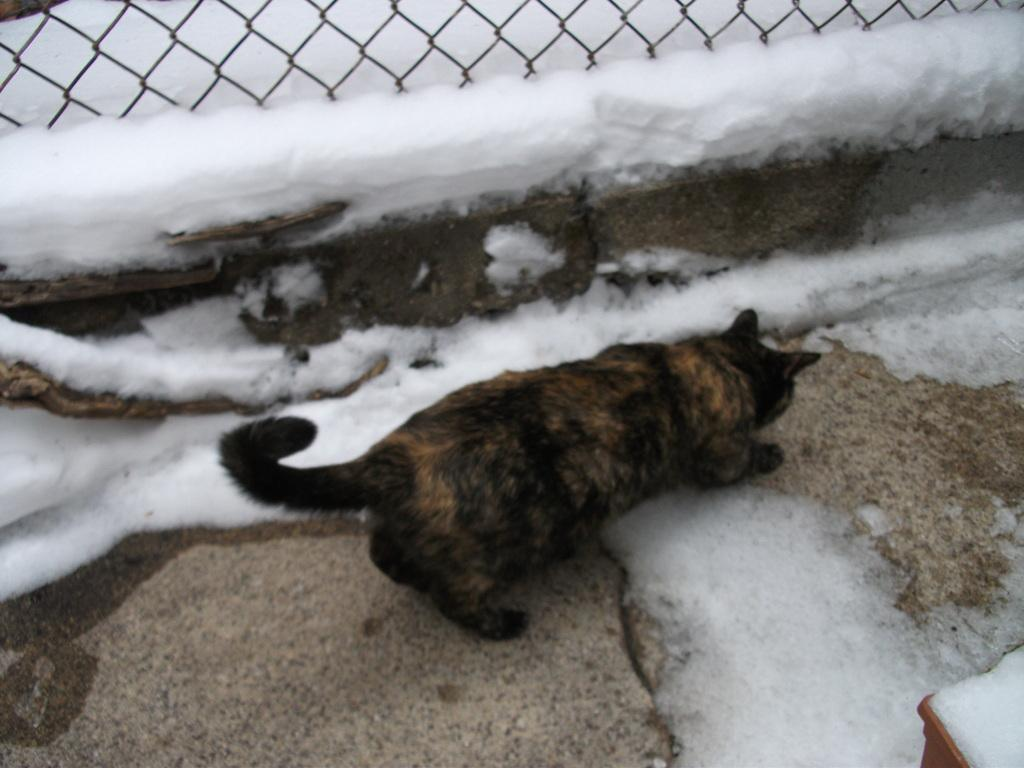What type of animal is in the image? The specific type of animal cannot be determined from the provided facts. What can be seen beneath the animal in the image? The ground is visible in the image. What substance is present in the image? There is lather in the image. What material is the metal object made of? The metal object is made of metal. Can you describe the object located at the bottom right corner of the image? The object at the bottom right corner of the image cannot be described with the provided facts. What type of hospital is visible in the image? There is no hospital present in the image. What color is the van in the image? There is no van present in the image. 